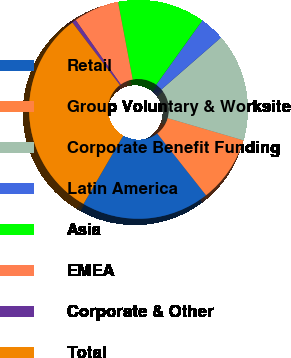<chart> <loc_0><loc_0><loc_500><loc_500><pie_chart><fcel>Retail<fcel>Group Voluntary & Worksite<fcel>Corporate Benefit Funding<fcel>Latin America<fcel>Asia<fcel>EMEA<fcel>Corporate & Other<fcel>Total<nl><fcel>19.02%<fcel>9.82%<fcel>15.95%<fcel>3.68%<fcel>12.88%<fcel>6.75%<fcel>0.61%<fcel>31.29%<nl></chart> 